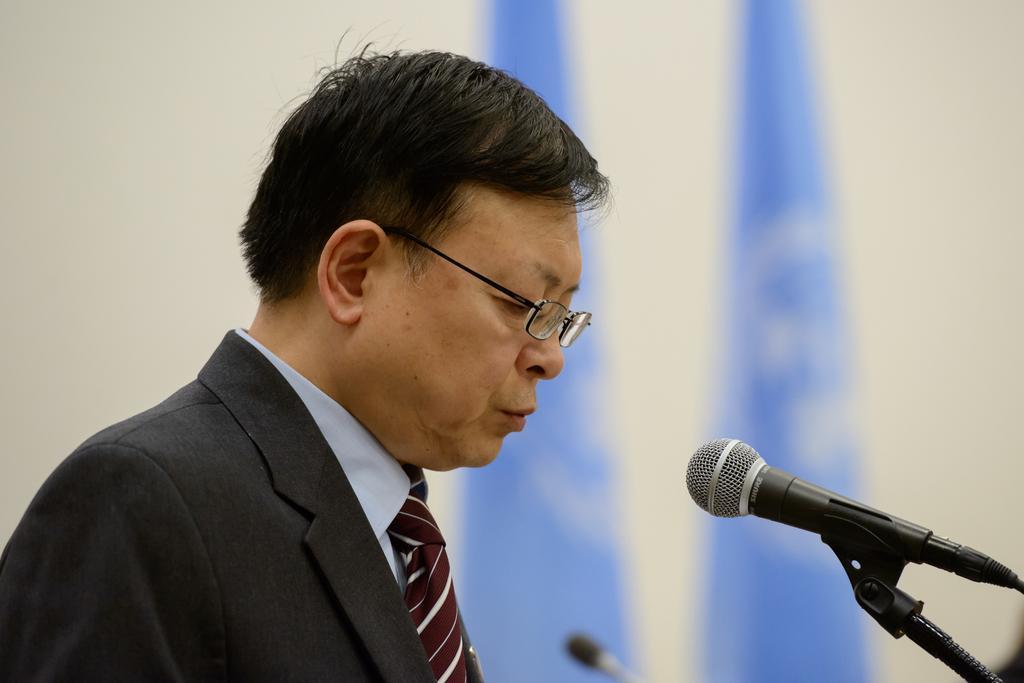Please provide a concise description of this image. In this image I can see a person visible in front of mike , background is white. 